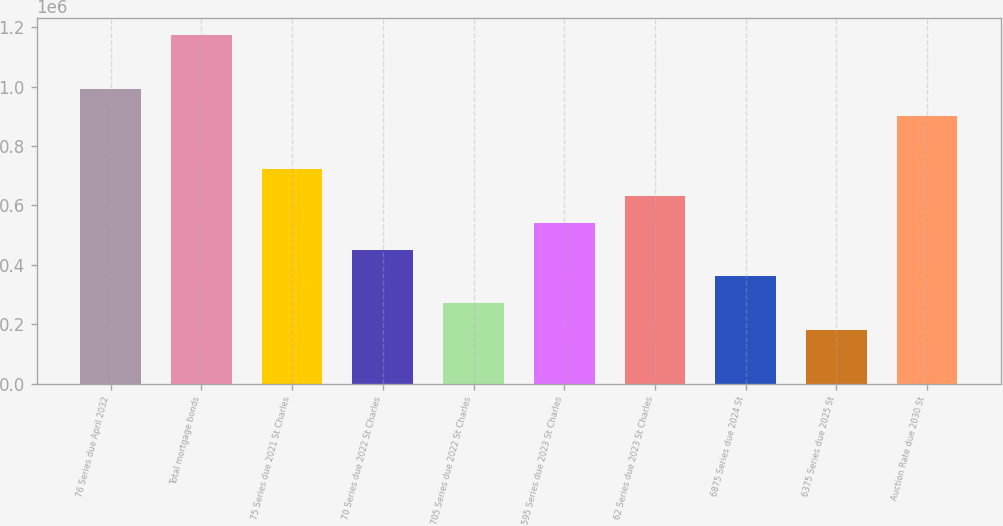<chart> <loc_0><loc_0><loc_500><loc_500><bar_chart><fcel>76 Series due April 2032<fcel>Total mortgage bonds<fcel>75 Series due 2021 St Charles<fcel>70 Series due 2022 St Charles<fcel>705 Series due 2022 St Charles<fcel>595 Series due 2023 St Charles<fcel>62 Series due 2023 St Charles<fcel>6875 Series due 2024 St<fcel>6375 Series due 2025 St<fcel>Auction Rate due 2030 St<nl><fcel>992608<fcel>1.17283e+06<fcel>722271<fcel>451934<fcel>271710<fcel>542047<fcel>632159<fcel>361822<fcel>181598<fcel>902496<nl></chart> 